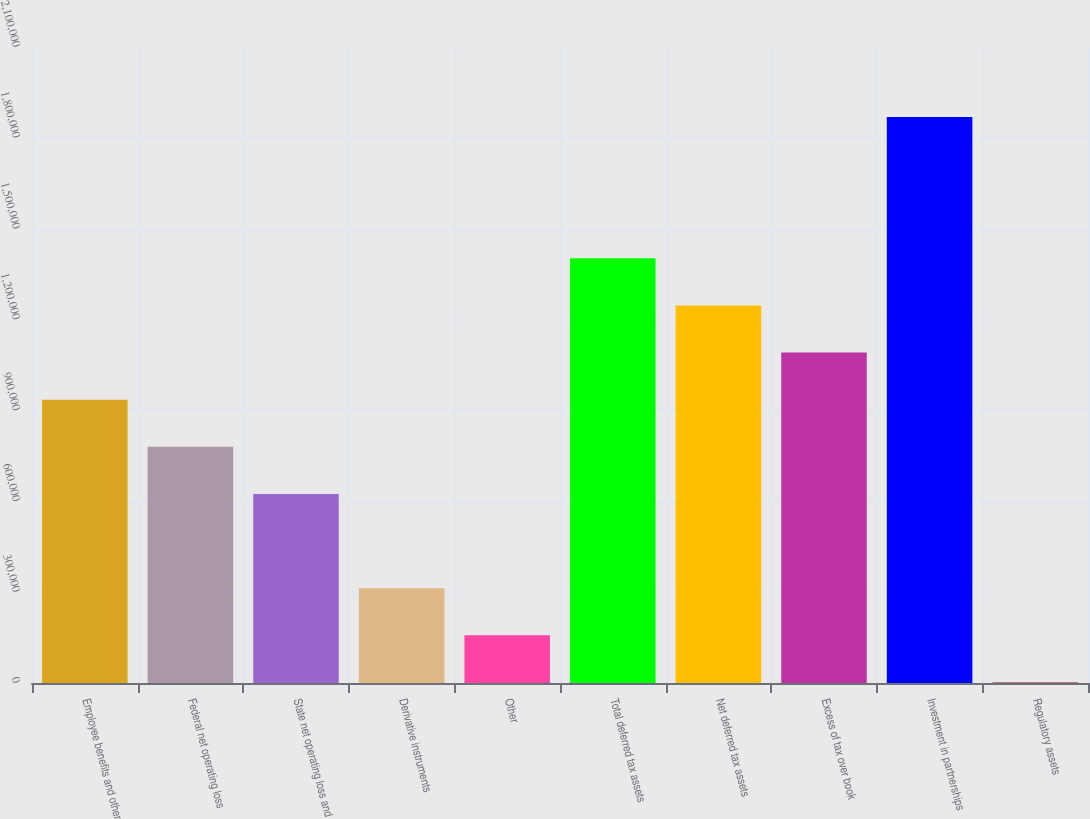Convert chart to OTSL. <chart><loc_0><loc_0><loc_500><loc_500><bar_chart><fcel>Employee benefits and other<fcel>Federal net operating loss<fcel>State net operating loss and<fcel>Derivative instruments<fcel>Other<fcel>Total deferred tax assets<fcel>Net deferred tax assets<fcel>Excess of tax over book<fcel>Investment in partnerships<fcel>Regulatory assets<nl><fcel>935462<fcel>779878<fcel>624295<fcel>313128<fcel>157544<fcel>1.40221e+06<fcel>1.24663e+06<fcel>1.09105e+06<fcel>1.86896e+06<fcel>1961<nl></chart> 